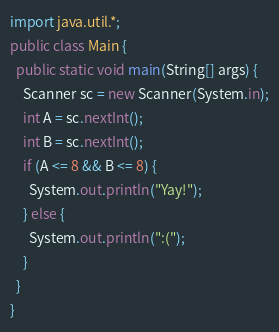<code> <loc_0><loc_0><loc_500><loc_500><_Java_>import java.util.*;
public class Main {
  public static void main(String[] args) {
    Scanner sc = new Scanner(System.in);
    int A = sc.nextInt();
    int B = sc.nextInt();
    if (A <= 8 && B <= 8) {
      System.out.println("Yay!");
    } else {
      System.out.println(":(");
    }
  }
}</code> 